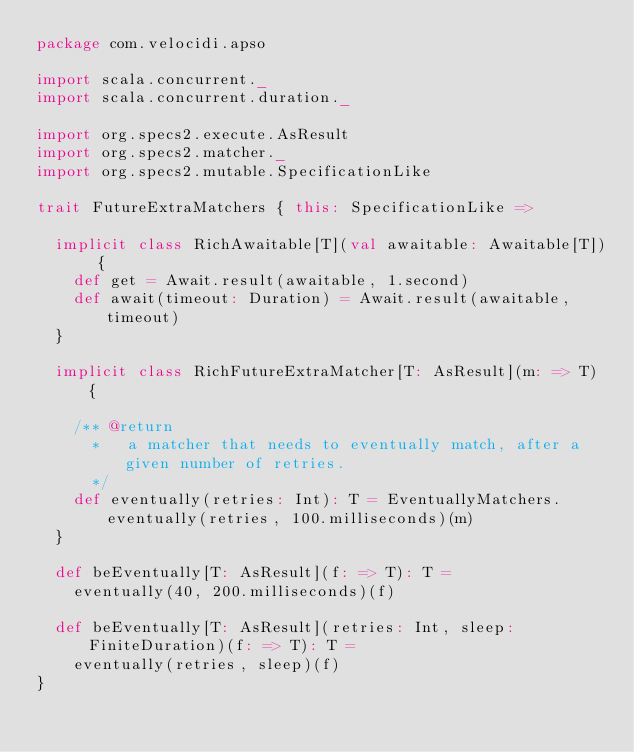Convert code to text. <code><loc_0><loc_0><loc_500><loc_500><_Scala_>package com.velocidi.apso

import scala.concurrent._
import scala.concurrent.duration._

import org.specs2.execute.AsResult
import org.specs2.matcher._
import org.specs2.mutable.SpecificationLike

trait FutureExtraMatchers { this: SpecificationLike =>

  implicit class RichAwaitable[T](val awaitable: Awaitable[T]) {
    def get = Await.result(awaitable, 1.second)
    def await(timeout: Duration) = Await.result(awaitable, timeout)
  }

  implicit class RichFutureExtraMatcher[T: AsResult](m: => T) {

    /** @return
      *   a matcher that needs to eventually match, after a given number of retries.
      */
    def eventually(retries: Int): T = EventuallyMatchers.eventually(retries, 100.milliseconds)(m)
  }

  def beEventually[T: AsResult](f: => T): T =
    eventually(40, 200.milliseconds)(f)

  def beEventually[T: AsResult](retries: Int, sleep: FiniteDuration)(f: => T): T =
    eventually(retries, sleep)(f)
}
</code> 